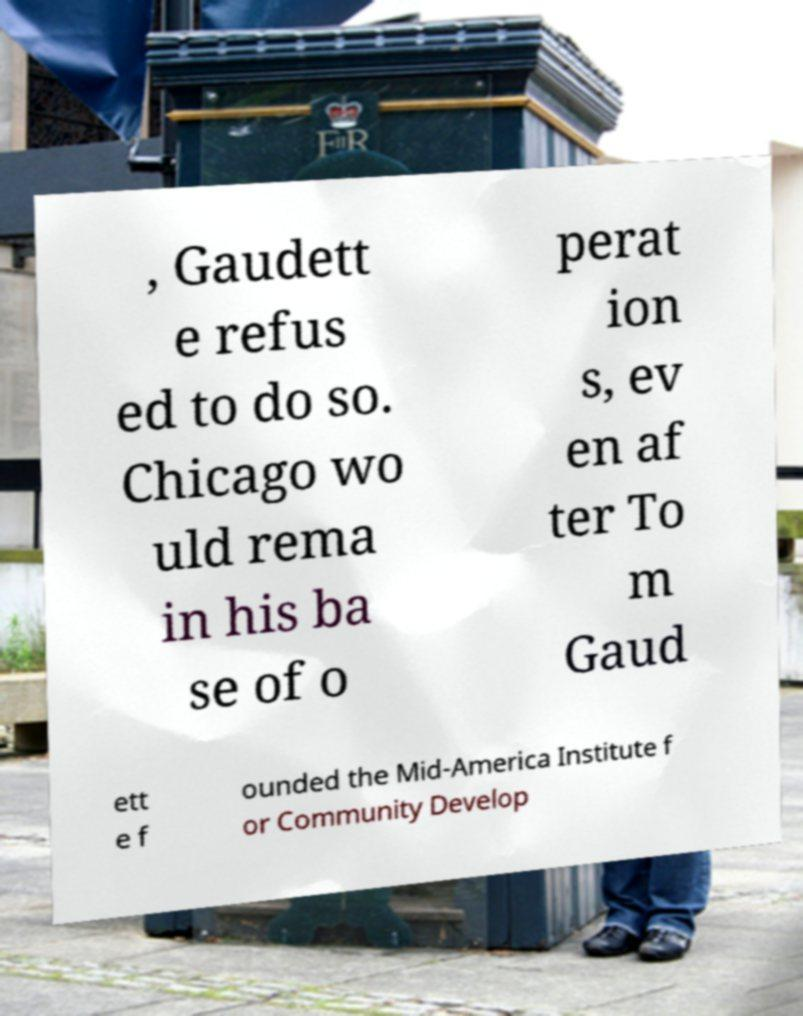Could you extract and type out the text from this image? , Gaudett e refus ed to do so. Chicago wo uld rema in his ba se of o perat ion s, ev en af ter To m Gaud ett e f ounded the Mid-America Institute f or Community Develop 